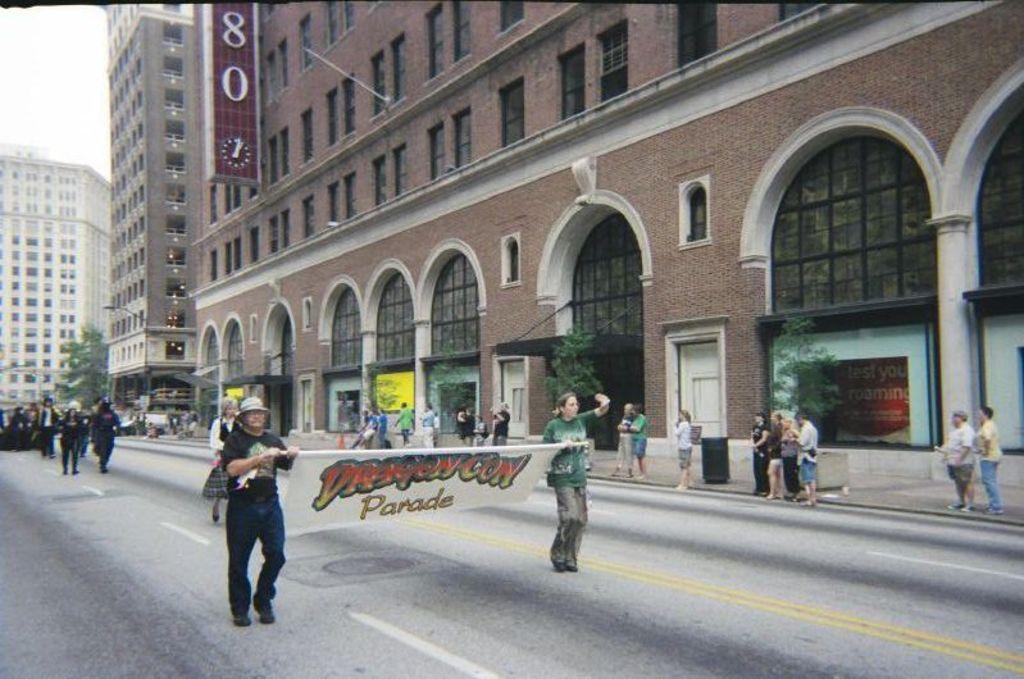Describe this image in one or two sentences. The image is taken on the streets of a city. In the foreground of the picture it is road, on the road there are many people. In the foreground there are two people holding a banner. In the center of the picture there are buildings, with, trees and board. On the footpath there are people standing. 